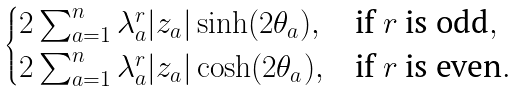Convert formula to latex. <formula><loc_0><loc_0><loc_500><loc_500>\begin{cases} 2 \sum _ { a = 1 } ^ { n } \lambda _ { a } ^ { r } | z _ { a } | \sinh ( 2 \theta _ { a } ) , & \text {if $r$ is odd} , \\ 2 \sum _ { a = 1 } ^ { n } \lambda _ { a } ^ { r } | z _ { a } | \cosh ( 2 \theta _ { a } ) , & \text {if $r$ is even} . \end{cases}</formula> 